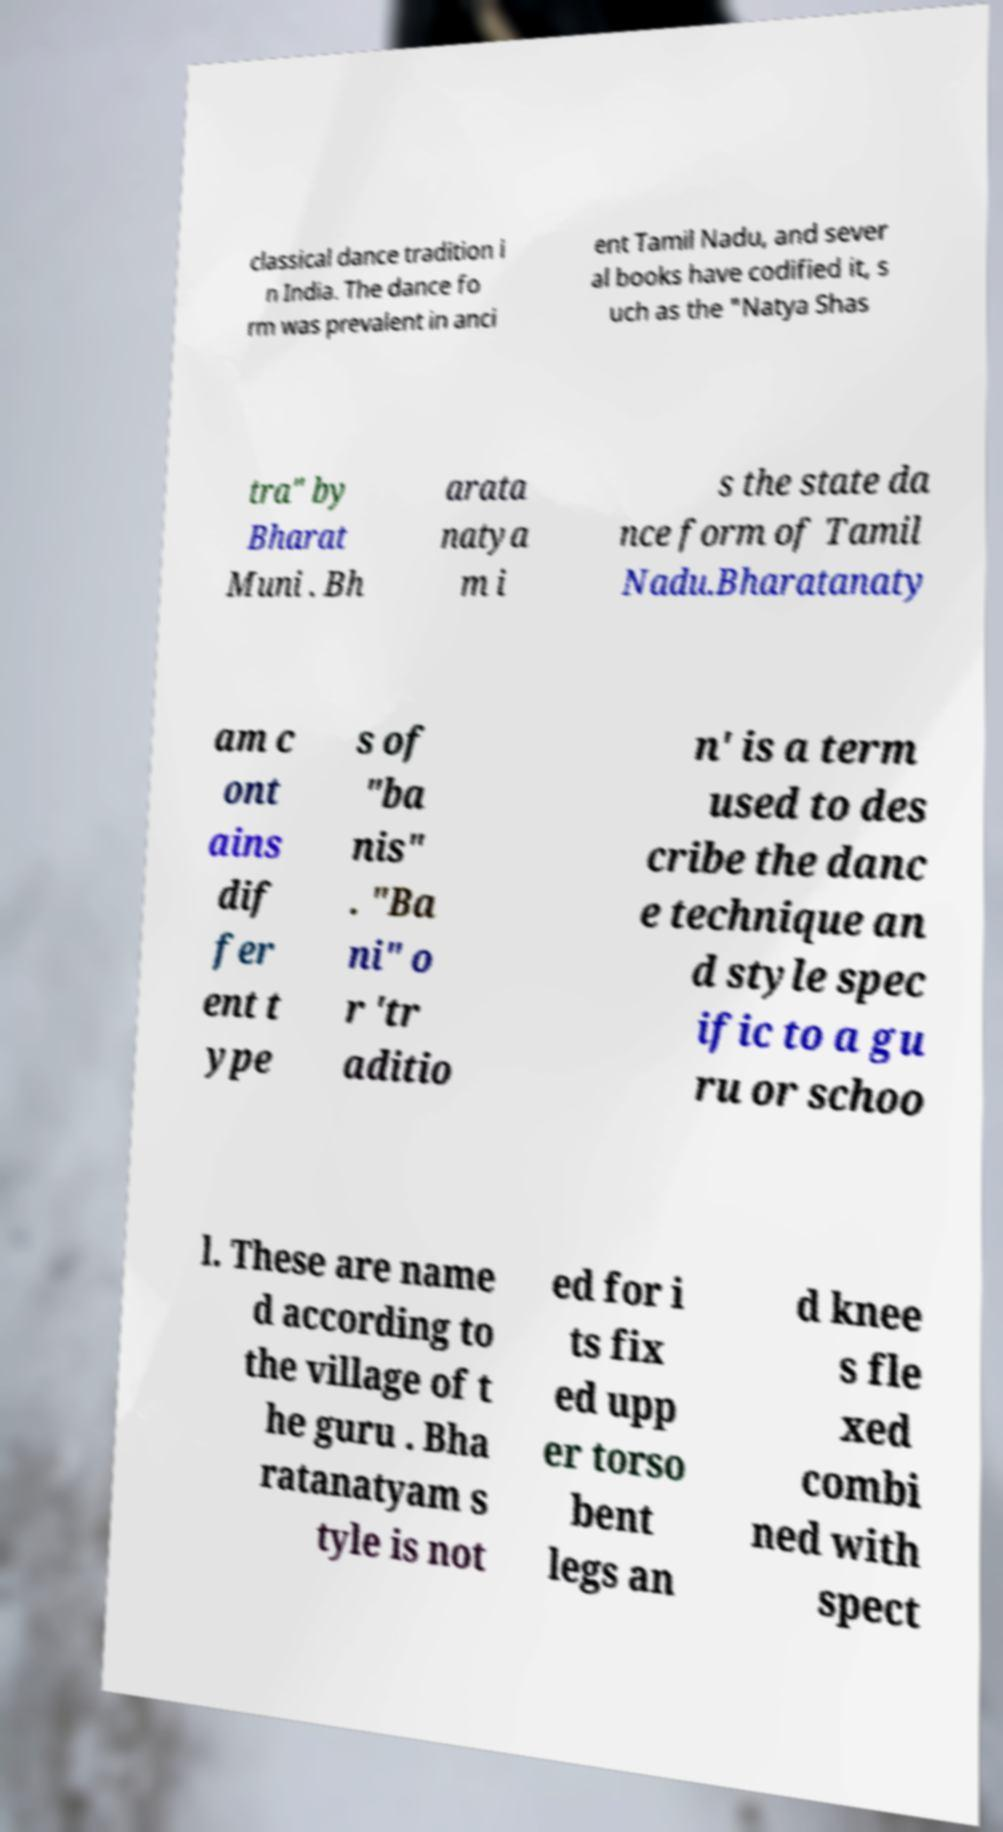Can you accurately transcribe the text from the provided image for me? classical dance tradition i n India. The dance fo rm was prevalent in anci ent Tamil Nadu, and sever al books have codified it, s uch as the "Natya Shas tra" by Bharat Muni . Bh arata natya m i s the state da nce form of Tamil Nadu.Bharatanaty am c ont ains dif fer ent t ype s of "ba nis" . "Ba ni" o r 'tr aditio n' is a term used to des cribe the danc e technique an d style spec ific to a gu ru or schoo l. These are name d according to the village of t he guru . Bha ratanatyam s tyle is not ed for i ts fix ed upp er torso bent legs an d knee s fle xed combi ned with spect 